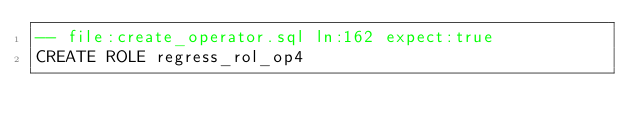<code> <loc_0><loc_0><loc_500><loc_500><_SQL_>-- file:create_operator.sql ln:162 expect:true
CREATE ROLE regress_rol_op4
</code> 